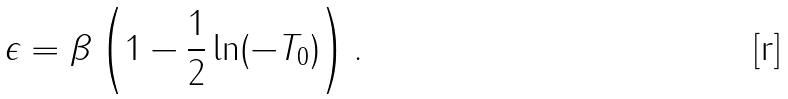Convert formula to latex. <formula><loc_0><loc_0><loc_500><loc_500>\epsilon = \beta \left ( 1 - \frac { 1 } { 2 } \ln ( - T _ { 0 } ) \right ) .</formula> 